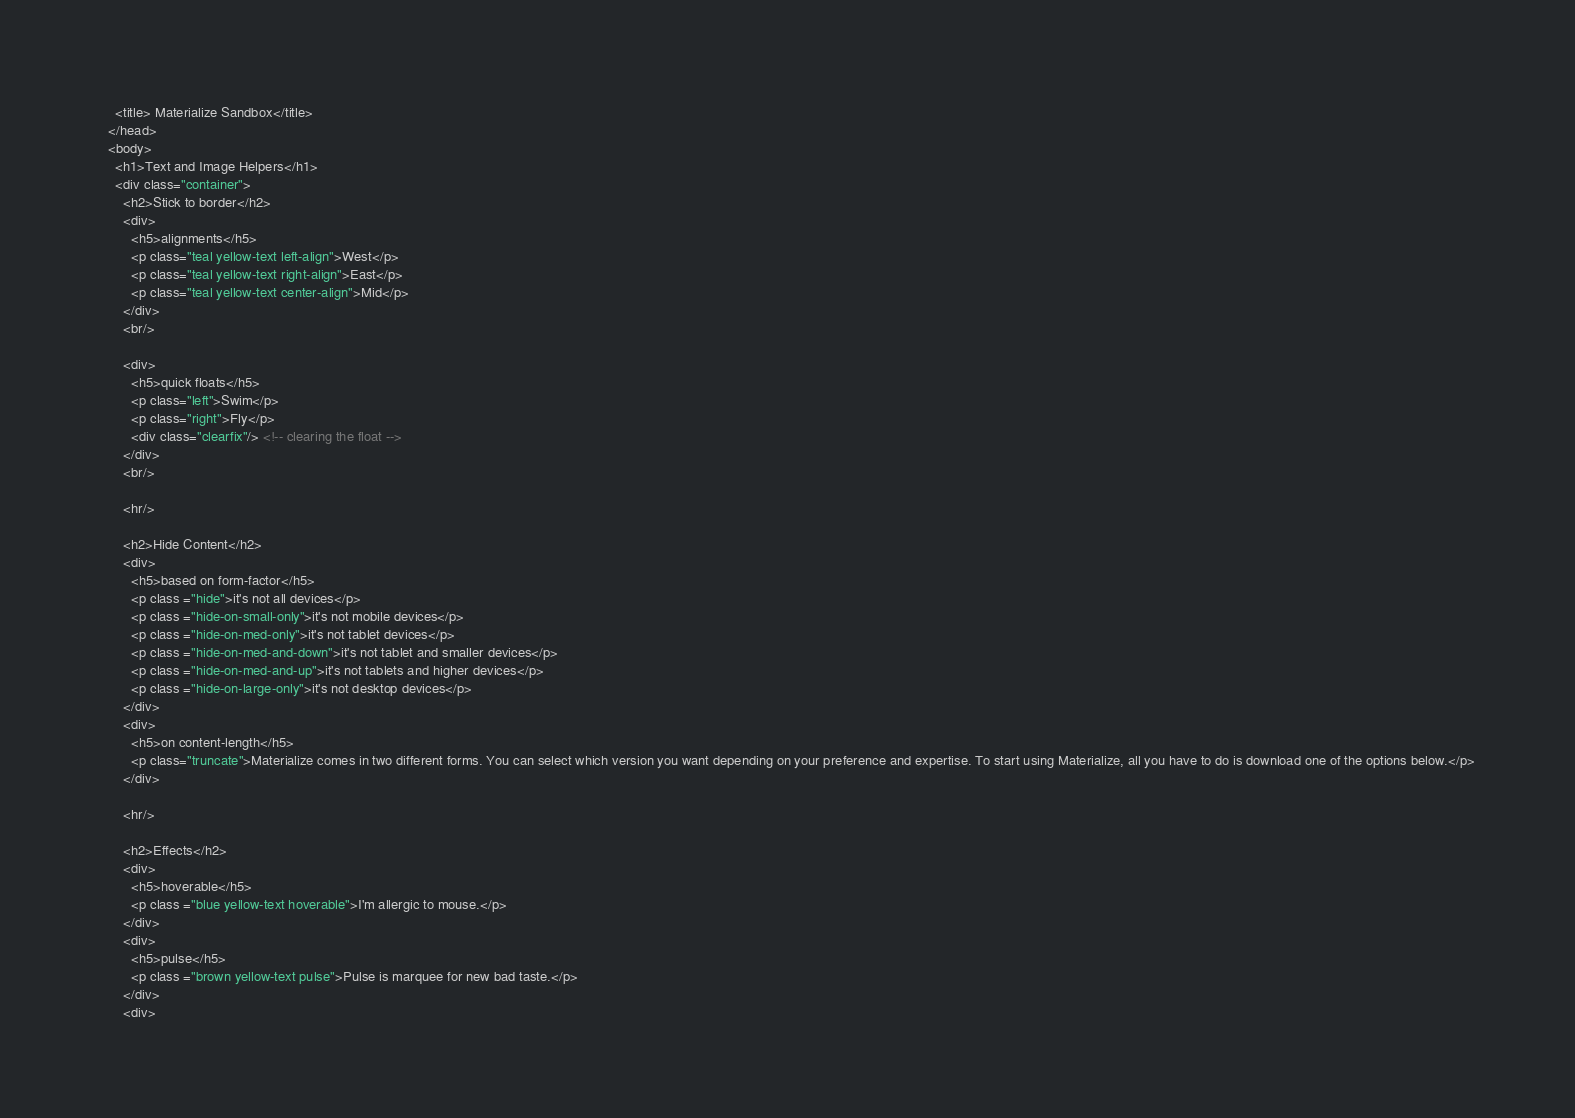Convert code to text. <code><loc_0><loc_0><loc_500><loc_500><_HTML_>
    <title> Materialize Sandbox</title>
  </head>
  <body>
    <h1>Text and Image Helpers</h1>
    <div class="container">
      <h2>Stick to border</h2>
      <div>
        <h5>alignments</h5>
        <p class="teal yellow-text left-align">West</p>
        <p class="teal yellow-text right-align">East</p>
        <p class="teal yellow-text center-align">Mid</p>
      </div>
      <br/>

      <div>
        <h5>quick floats</h5>
        <p class="left">Swim</p>
        <p class="right">Fly</p>
        <div class="clearfix"/> <!-- clearing the float -->
      </div>
      <br/>

      <hr/>

      <h2>Hide Content</h2>
      <div>
        <h5>based on form-factor</h5>
        <p class ="hide">it's not all devices</p>
        <p class ="hide-on-small-only">it's not mobile devices</p>
        <p class ="hide-on-med-only">it's not tablet devices</p>
        <p class ="hide-on-med-and-down">it's not tablet and smaller devices</p>
        <p class ="hide-on-med-and-up">it's not tablets and higher devices</p>
        <p class ="hide-on-large-only">it's not desktop devices</p>
      </div>
      <div>
        <h5>on content-length</h5>
        <p class="truncate">Materialize comes in two different forms. You can select which version you want depending on your preference and expertise. To start using Materialize, all you have to do is download one of the options below.</p>
      </div>

      <hr/>

      <h2>Effects</h2>
      <div>
        <h5>hoverable</h5>
        <p class ="blue yellow-text hoverable">I'm allergic to mouse.</p>
      </div>
      <div>
        <h5>pulse</h5>
        <p class ="brown yellow-text pulse">Pulse is marquee for new bad taste.</p>
      </div>
      <div></code> 